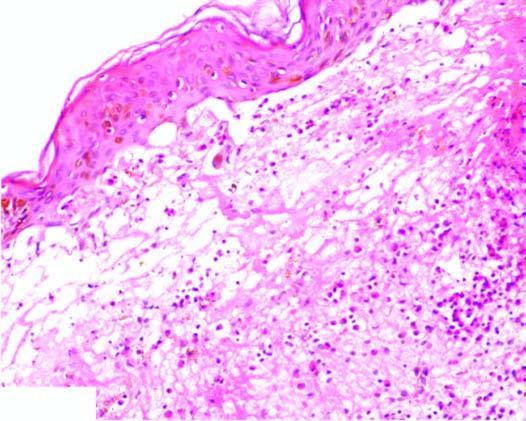what do the tips of dermal papillae show?
Answer the question using a single word or phrase. Neutrophilic microabscess causing dermo-epidermal separation at tips 